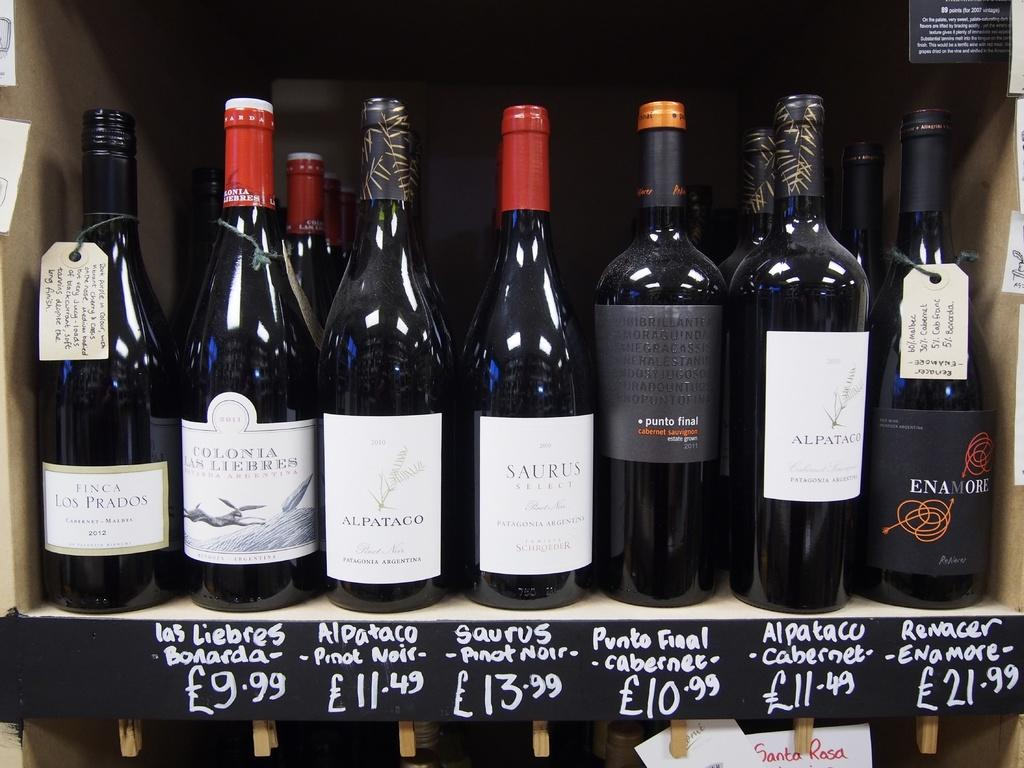<image>
Relay a brief, clear account of the picture shown. Different types of wine on display in a British store including Punto Final Cabernet for 10.99. 